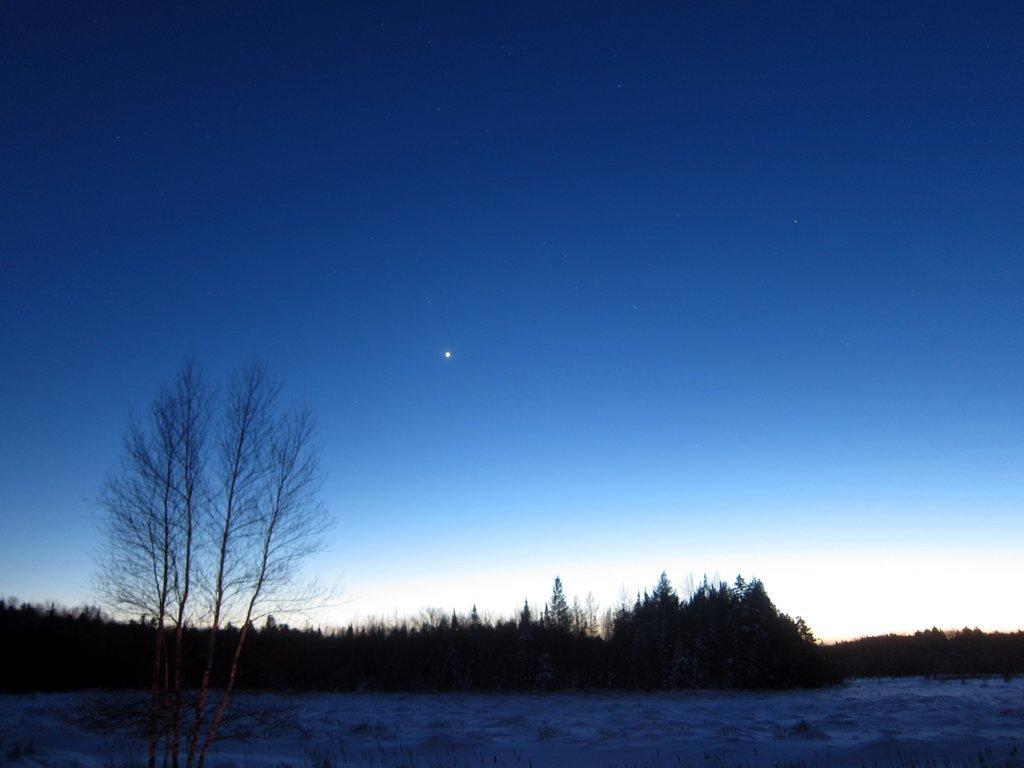Describe this image in one or two sentences. In this image there is a dry tree in the front. In the background there are trees. 